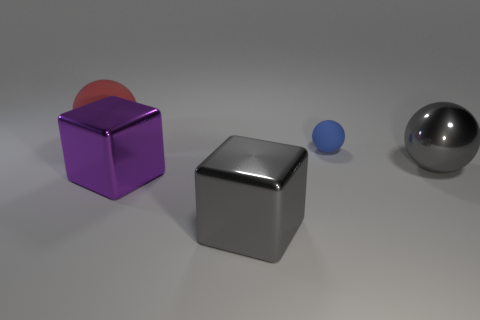Add 4 big red balls. How many objects exist? 9 Subtract all matte balls. How many balls are left? 1 Subtract 1 spheres. How many spheres are left? 2 Subtract all gray balls. How many balls are left? 2 Subtract all cubes. How many objects are left? 3 Add 3 gray metal spheres. How many gray metal spheres are left? 4 Add 2 tiny blue spheres. How many tiny blue spheres exist? 3 Subtract 1 red spheres. How many objects are left? 4 Subtract all green cubes. Subtract all cyan spheres. How many cubes are left? 2 Subtract all big matte things. Subtract all small blue cylinders. How many objects are left? 4 